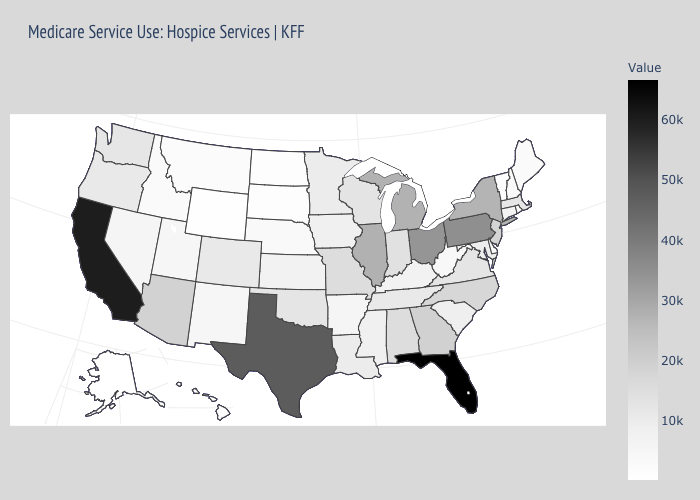Among the states that border Massachusetts , which have the highest value?
Concise answer only. New York. Does Florida have the highest value in the USA?
Answer briefly. Yes. Does Louisiana have a higher value than Georgia?
Answer briefly. No. Which states have the lowest value in the Northeast?
Be succinct. Vermont. Which states have the lowest value in the MidWest?
Concise answer only. South Dakota. 